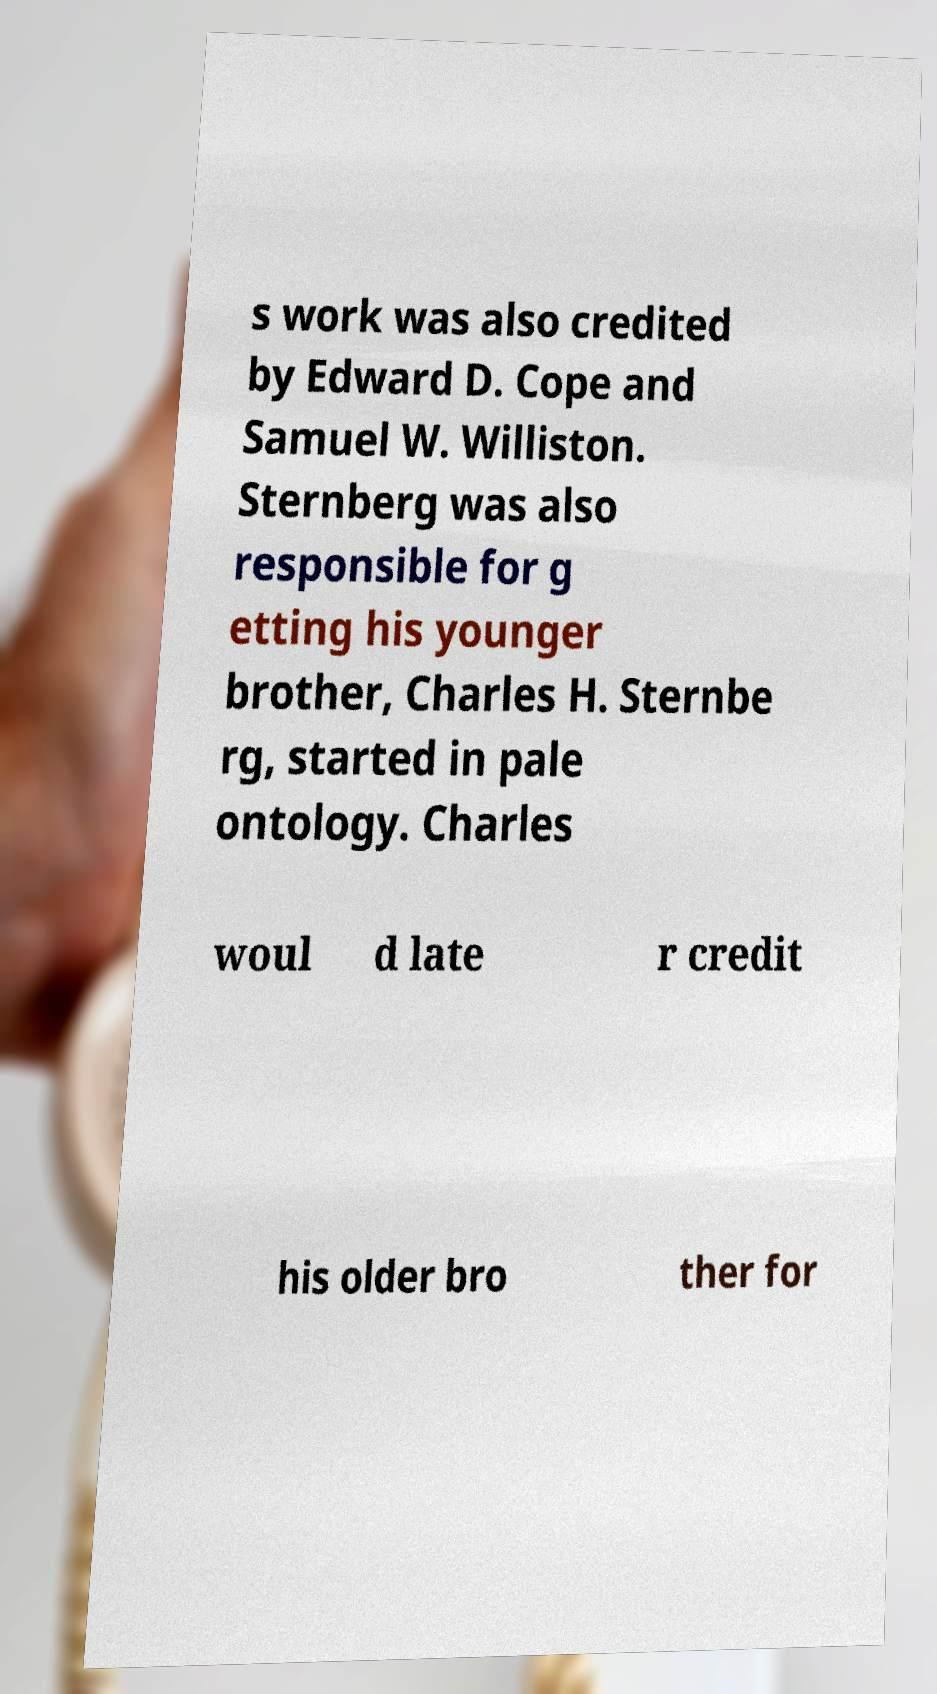What messages or text are displayed in this image? I need them in a readable, typed format. s work was also credited by Edward D. Cope and Samuel W. Williston. Sternberg was also responsible for g etting his younger brother, Charles H. Sternbe rg, started in pale ontology. Charles woul d late r credit his older bro ther for 